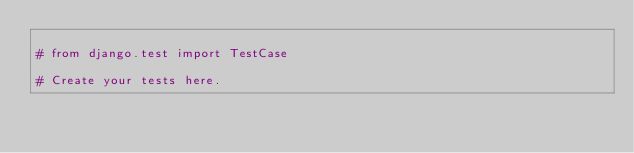Convert code to text. <code><loc_0><loc_0><loc_500><loc_500><_Python_>
# from django.test import TestCase

# Create your tests here.
</code> 